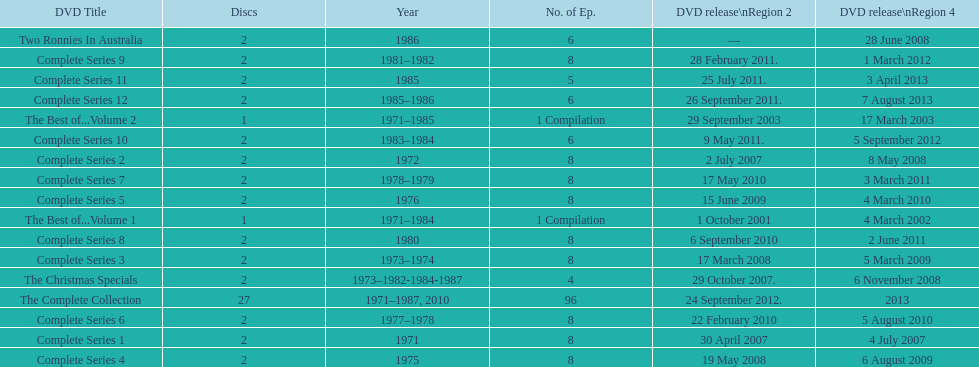The complete collection has 96 episodes, but the christmas specials only has how many episodes? 4. 